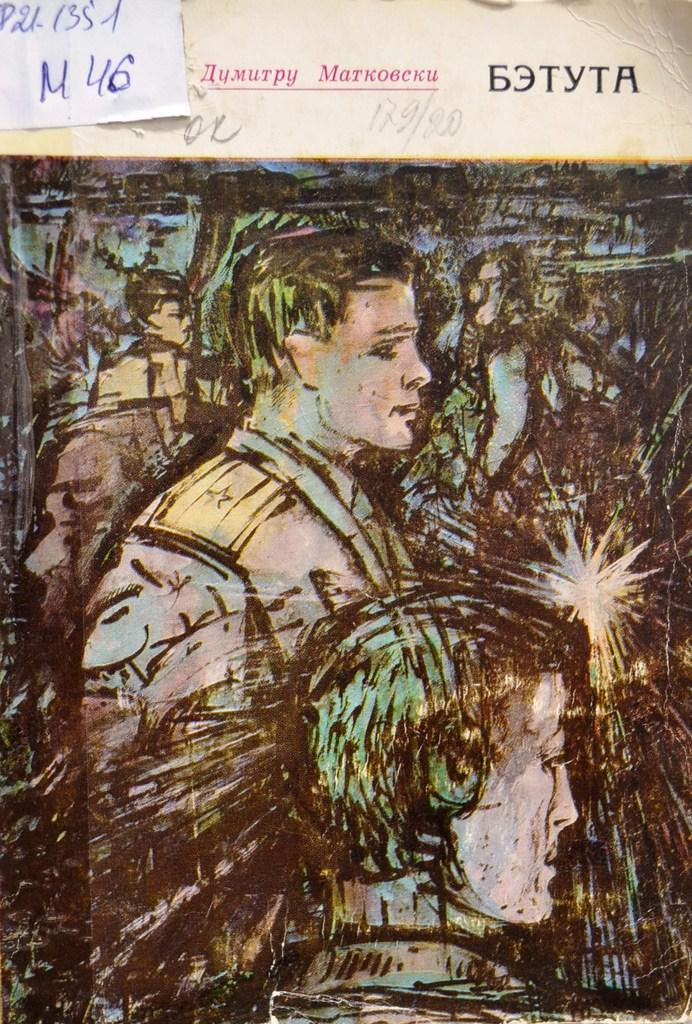What type of page is shown in the image? The image is a cover page of a book. What can be seen on the cover page? There are people depicted on the cover page. Is there any text visible on the cover page? Yes, there is text visible on the top of the image. What type of board is being used by the people in the image? There is no board present in the image; it only shows people on the cover page of a book. What town is depicted in the image? The image does not depict a town; it is a cover page of a book with people on it. 